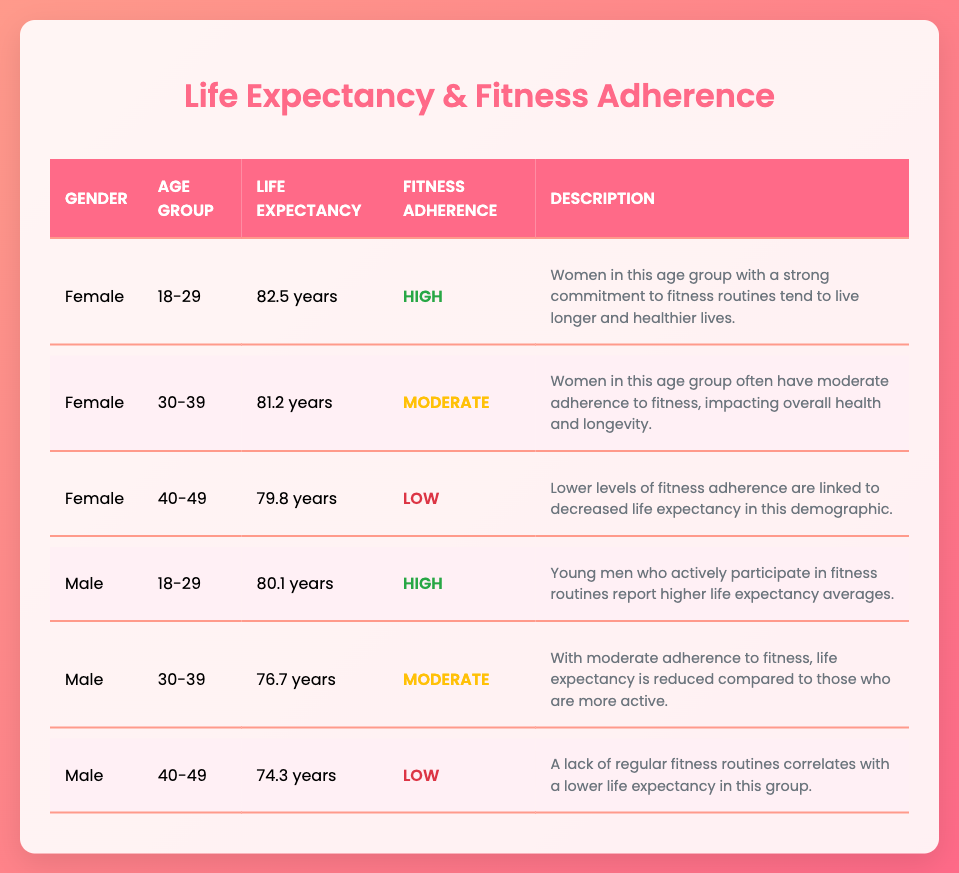What is the average life expectancy of females aged 30-39? According to the table, the average life expectancy for females aged 30-39 is listed as 81.2 years. Thus, the answer is directly retrieved from the corresponding row.
Answer: 81.2 years How many years do males aged 40-49 live on average? The table shows that males aged 40-49 have an average life expectancy of 74.3 years, which is stated in their row under that age group.
Answer: 74.3 years Is it true that women's life expectancy decreases with lower fitness adherence in the 40-49 age group? In the table, the description for females in the 40-49 age group states that lower levels of fitness adherence are linked to decreased life expectancy, supporting that the statement is accurate.
Answer: Yes What is the difference in average life expectancy between females aged 18-29 and males aged 18-29? From the table, females aged 18-29 have an average life expectancy of 82.5 years, and males in the same age group have an average of 80.1 years. The difference is calculated as 82.5 - 80.1 = 2.4 years.
Answer: 2.4 years Which gender in the 30-39 age group has a higher life expectancy with moderate fitness adherence? By reviewing the data, females in the 30-39 age group have an average life expectancy of 81.2 years, while males in the same age group have an average of 76.7 years. Thus, females have a higher life expectancy.
Answer: Female What is the average life expectancy for all age groups of females? To find the average, we take the life expectancies for females across the three age groups: 82.5 (18-29) + 81.2 (30-39) + 79.8 (40-49) = 243.5 years. To find the average, we divide by 3, which results in 243.5 / 3 = 81.17 years (rounded to two decimal places).
Answer: 81.17 years 